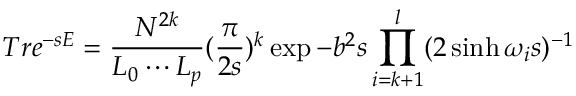<formula> <loc_0><loc_0><loc_500><loc_500>T r e ^ { - s E } = \frac { N ^ { 2 k } } { L _ { 0 } \cdots L _ { p } } ( \frac { \pi } { 2 s } ) ^ { k } \exp { - b ^ { 2 } s } \prod _ { i = k + 1 } ^ { l } ( 2 \sinh \omega _ { i } s ) ^ { - 1 }</formula> 